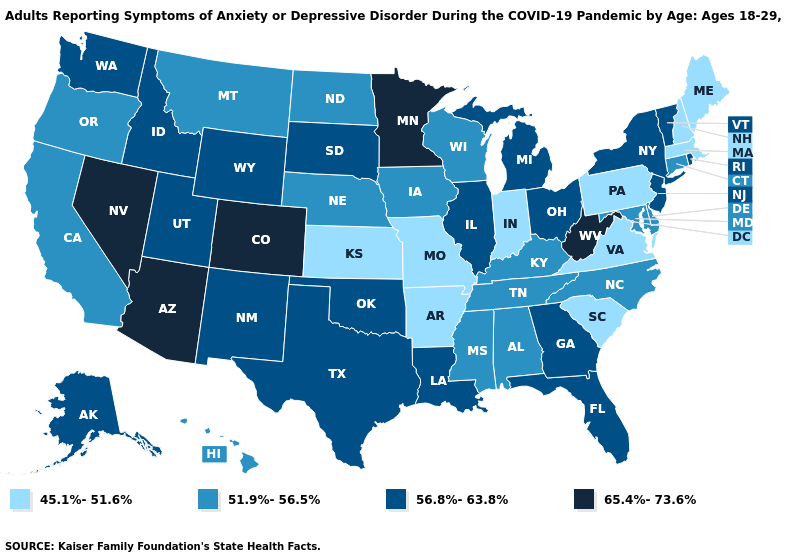Which states hav the highest value in the West?
Concise answer only. Arizona, Colorado, Nevada. Name the states that have a value in the range 45.1%-51.6%?
Concise answer only. Arkansas, Indiana, Kansas, Maine, Massachusetts, Missouri, New Hampshire, Pennsylvania, South Carolina, Virginia. Which states have the lowest value in the MidWest?
Quick response, please. Indiana, Kansas, Missouri. What is the value of New Jersey?
Write a very short answer. 56.8%-63.8%. What is the value of Oklahoma?
Write a very short answer. 56.8%-63.8%. Among the states that border Connecticut , does New York have the lowest value?
Be succinct. No. Does the first symbol in the legend represent the smallest category?
Keep it brief. Yes. What is the highest value in states that border Rhode Island?
Write a very short answer. 51.9%-56.5%. Name the states that have a value in the range 51.9%-56.5%?
Quick response, please. Alabama, California, Connecticut, Delaware, Hawaii, Iowa, Kentucky, Maryland, Mississippi, Montana, Nebraska, North Carolina, North Dakota, Oregon, Tennessee, Wisconsin. Does Texas have the lowest value in the USA?
Short answer required. No. Does Colorado have the highest value in the USA?
Quick response, please. Yes. Does Arizona have the highest value in the USA?
Write a very short answer. Yes. Among the states that border Tennessee , does Alabama have the lowest value?
Quick response, please. No. Does Connecticut have the highest value in the Northeast?
Concise answer only. No. Among the states that border Oregon , does Idaho have the highest value?
Give a very brief answer. No. 